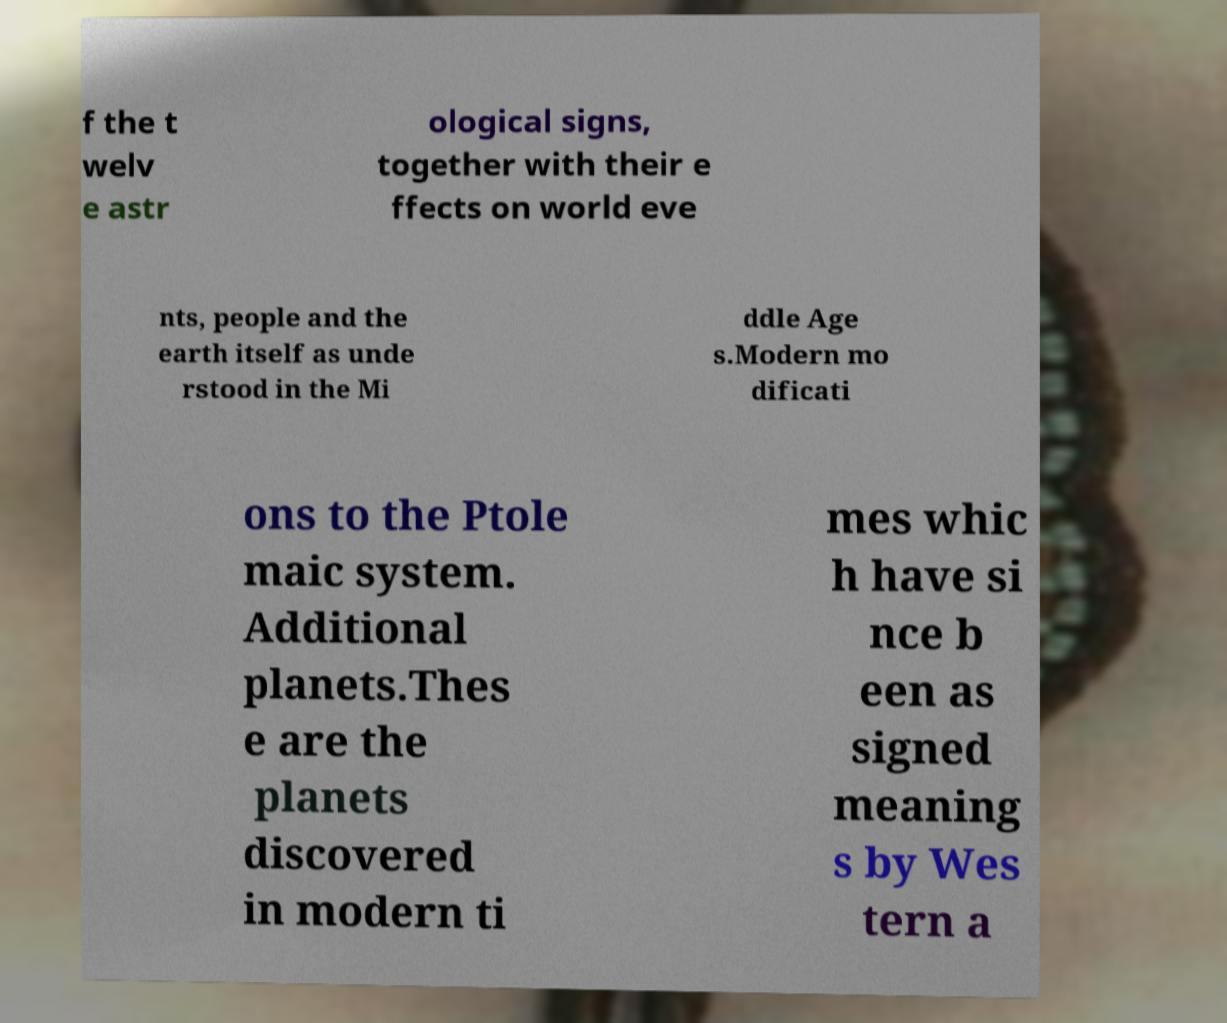Could you assist in decoding the text presented in this image and type it out clearly? f the t welv e astr ological signs, together with their e ffects on world eve nts, people and the earth itself as unde rstood in the Mi ddle Age s.Modern mo dificati ons to the Ptole maic system. Additional planets.Thes e are the planets discovered in modern ti mes whic h have si nce b een as signed meaning s by Wes tern a 